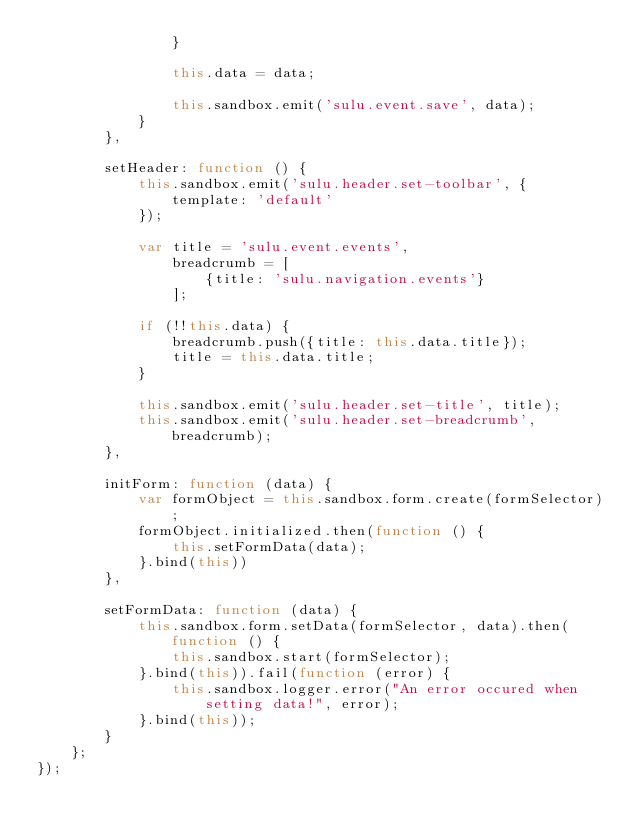Convert code to text. <code><loc_0><loc_0><loc_500><loc_500><_JavaScript_>                }

                this.data = data;

                this.sandbox.emit('sulu.event.save', data);
            }
        },

        setHeader: function () {
            this.sandbox.emit('sulu.header.set-toolbar', {
                template: 'default'
            });

            var title = 'sulu.event.events',
                breadcrumb = [
                    {title: 'sulu.navigation.events'}
                ];

            if (!!this.data) {
                breadcrumb.push({title: this.data.title});
                title = this.data.title;
            }

            this.sandbox.emit('sulu.header.set-title', title);
            this.sandbox.emit('sulu.header.set-breadcrumb', breadcrumb);
        },

        initForm: function (data) {
            var formObject = this.sandbox.form.create(formSelector);
            formObject.initialized.then(function () {
                this.setFormData(data);
            }.bind(this))
        },

        setFormData: function (data) {
            this.sandbox.form.setData(formSelector, data).then(function () {
                this.sandbox.start(formSelector);
            }.bind(this)).fail(function (error) {
                this.sandbox.logger.error("An error occured when setting data!", error);
            }.bind(this));
        }
    };
});
</code> 